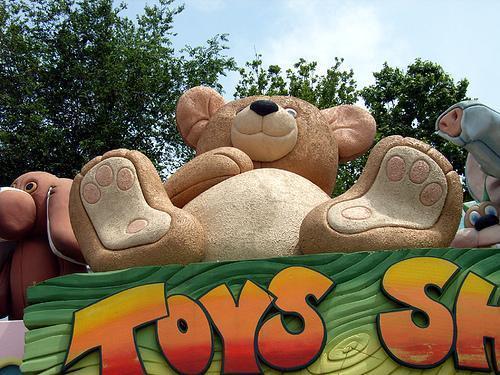How many letters are seen in the picture?
Give a very brief answer. 6. 